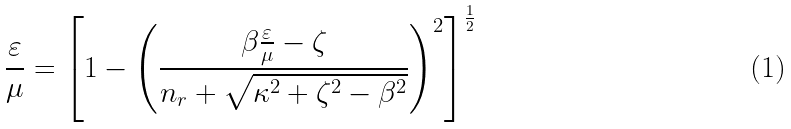<formula> <loc_0><loc_0><loc_500><loc_500>\frac { \varepsilon } { \mu } = \left [ 1 - \left ( \frac { \beta \frac { \varepsilon } { \mu } - \zeta } { n _ { r } + \sqrt { \kappa ^ { 2 } + \zeta ^ { 2 } - \beta ^ { 2 } } } \right ) ^ { 2 } \right ] ^ { \frac { 1 } { 2 } }</formula> 